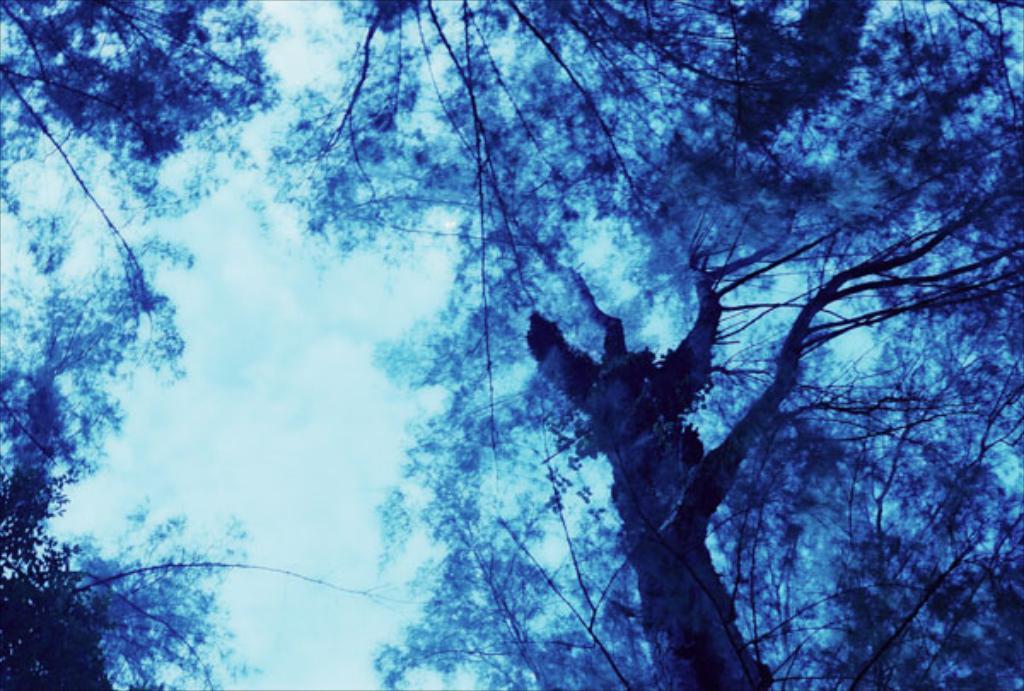Could you give a brief overview of what you see in this image? In this picture, we can see some trees. In the background, we can see a sky. 